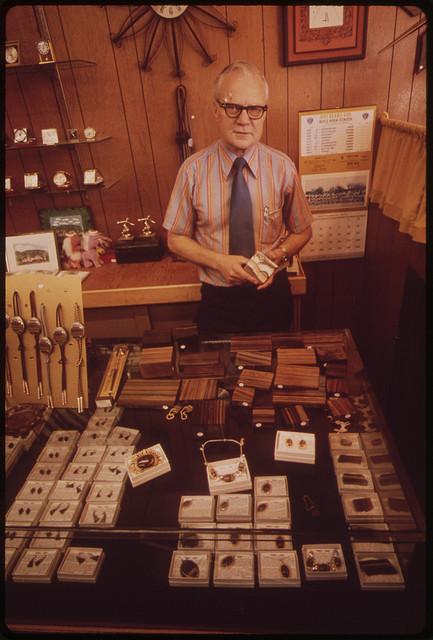What is the man selling?
Short answer required. Jewelry. What pattern is on the wall?
Write a very short answer. Stripes. What color are the walls?
Concise answer only. Brown. What is the man wearing?
Write a very short answer. Shirt and tie. 